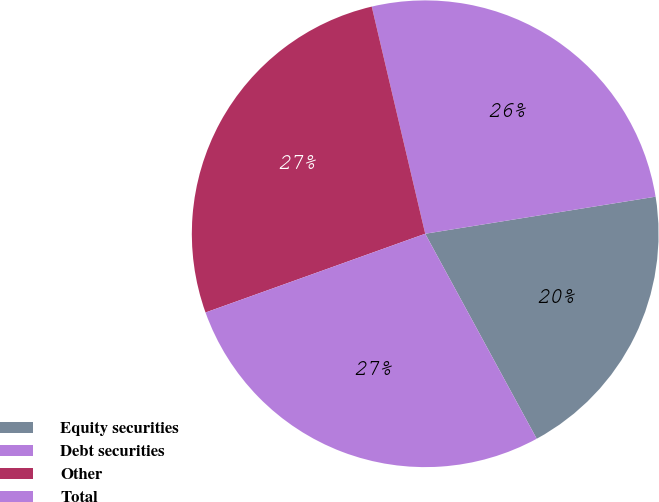Convert chart. <chart><loc_0><loc_0><loc_500><loc_500><pie_chart><fcel>Equity securities<fcel>Debt securities<fcel>Other<fcel>Total<nl><fcel>19.61%<fcel>26.14%<fcel>26.8%<fcel>27.45%<nl></chart> 